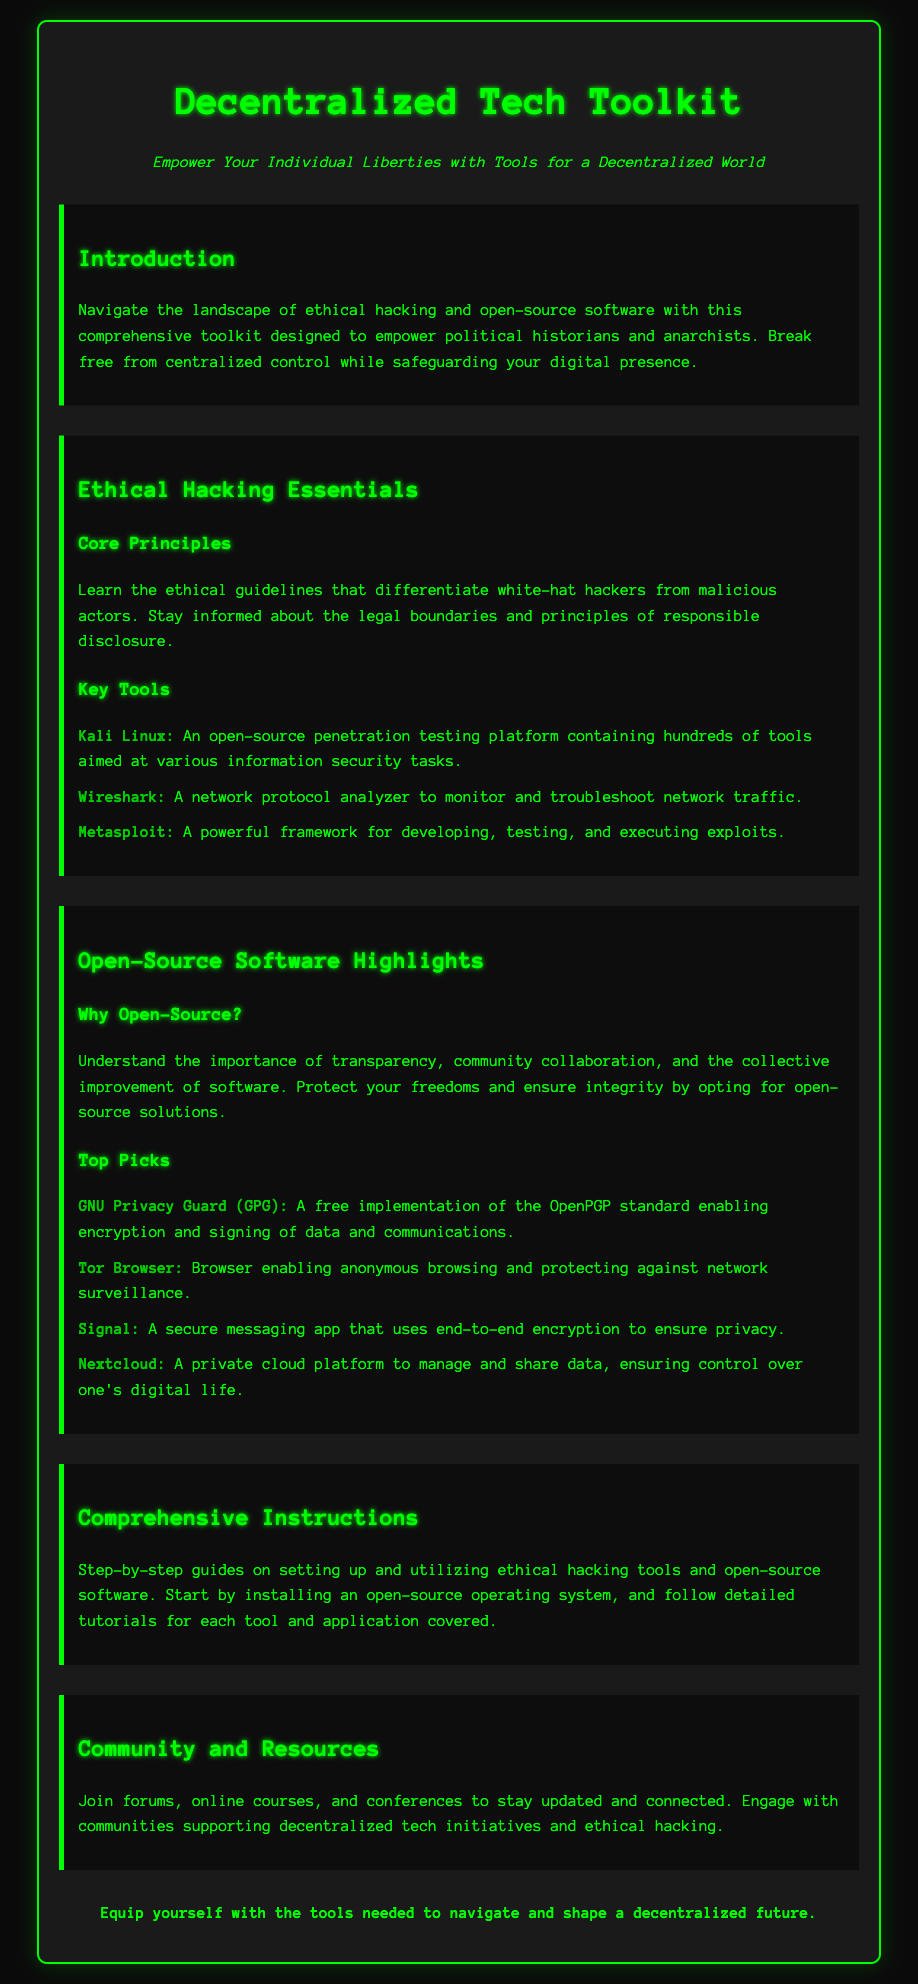What is the title of the document? The title of the document is displayed prominently at the top, indicating the focus of the content.
Answer: Decentralized Tech Toolkit What is the tagline of the document? The tagline summarizes the document's purpose and is prominently placed below the title.
Answer: Empower Your Individual Liberties with Tools for a Decentralized World Which ethical hacking tool is described as a powerful framework? The document lists various tools and describes their functions; one of them is highlighted as a framework for testing.
Answer: Metasploit What software is recommended for anonymous browsing? The document includes a list of top picks for open-source software, referencing the tool intended for anonymous internet use.
Answer: Tor Browser What is the purpose of GNU Privacy Guard? The document describes the function of this tool, emphasizing its role relating to data security.
Answer: Encrypting and signing data and communications How many key ethical hacking tools are mentioned? The document provides a list of essential tools for ethical hacking; the count can be directly observed in the section.
Answer: Three What is the focus of the "Comprehensive Instructions" section? The section details the objective of providing thorough guides related to tool usage and setup.
Answer: Step-by-step guides Which community resource is suggested for engagement in decentralized tech? The document lists types of resources to engage with, where one falls under community-related interactions.
Answer: Forums What is the main focus of the toolkit? The introduction provides insight into the primary audience and intention of the toolkit.
Answer: Ethical hacking and open-source software 